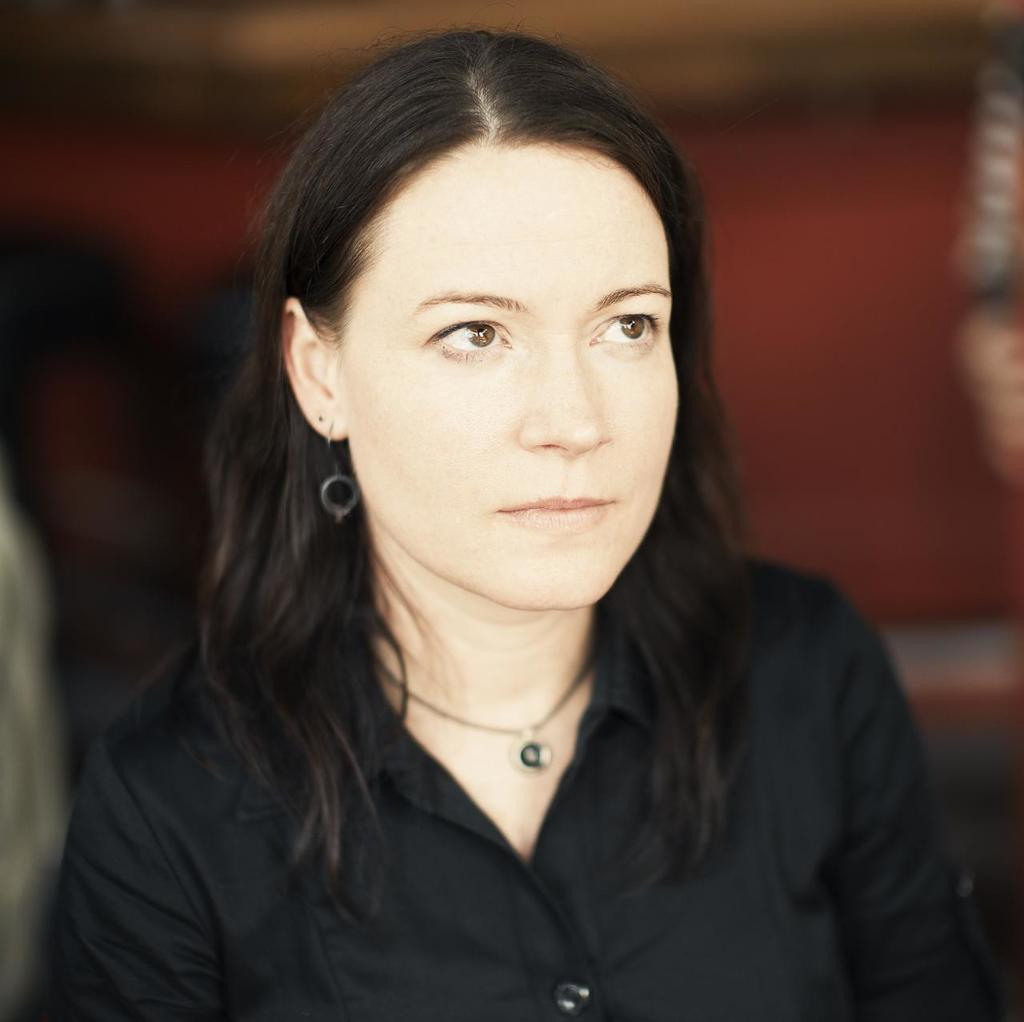Who is the main subject in the picture? There is a woman in the picture. What is the woman wearing? The woman is wearing a black shirt. In which direction is the woman looking? The woman is looking to the right side. Can you describe the background of the picture? The backdrop is blurred. What type of string can be seen in the woman's hand in the image? There is no string visible in the woman's hand in the image. 